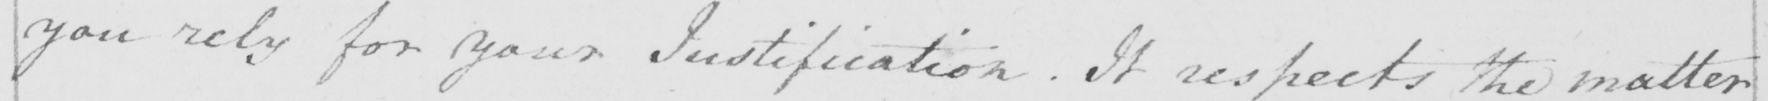Can you tell me what this handwritten text says? you rely for your Justifiation . It respects the matter 